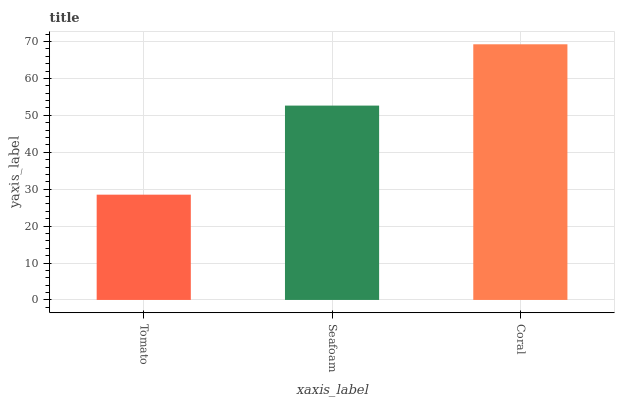Is Tomato the minimum?
Answer yes or no. Yes. Is Coral the maximum?
Answer yes or no. Yes. Is Seafoam the minimum?
Answer yes or no. No. Is Seafoam the maximum?
Answer yes or no. No. Is Seafoam greater than Tomato?
Answer yes or no. Yes. Is Tomato less than Seafoam?
Answer yes or no. Yes. Is Tomato greater than Seafoam?
Answer yes or no. No. Is Seafoam less than Tomato?
Answer yes or no. No. Is Seafoam the high median?
Answer yes or no. Yes. Is Seafoam the low median?
Answer yes or no. Yes. Is Coral the high median?
Answer yes or no. No. Is Coral the low median?
Answer yes or no. No. 